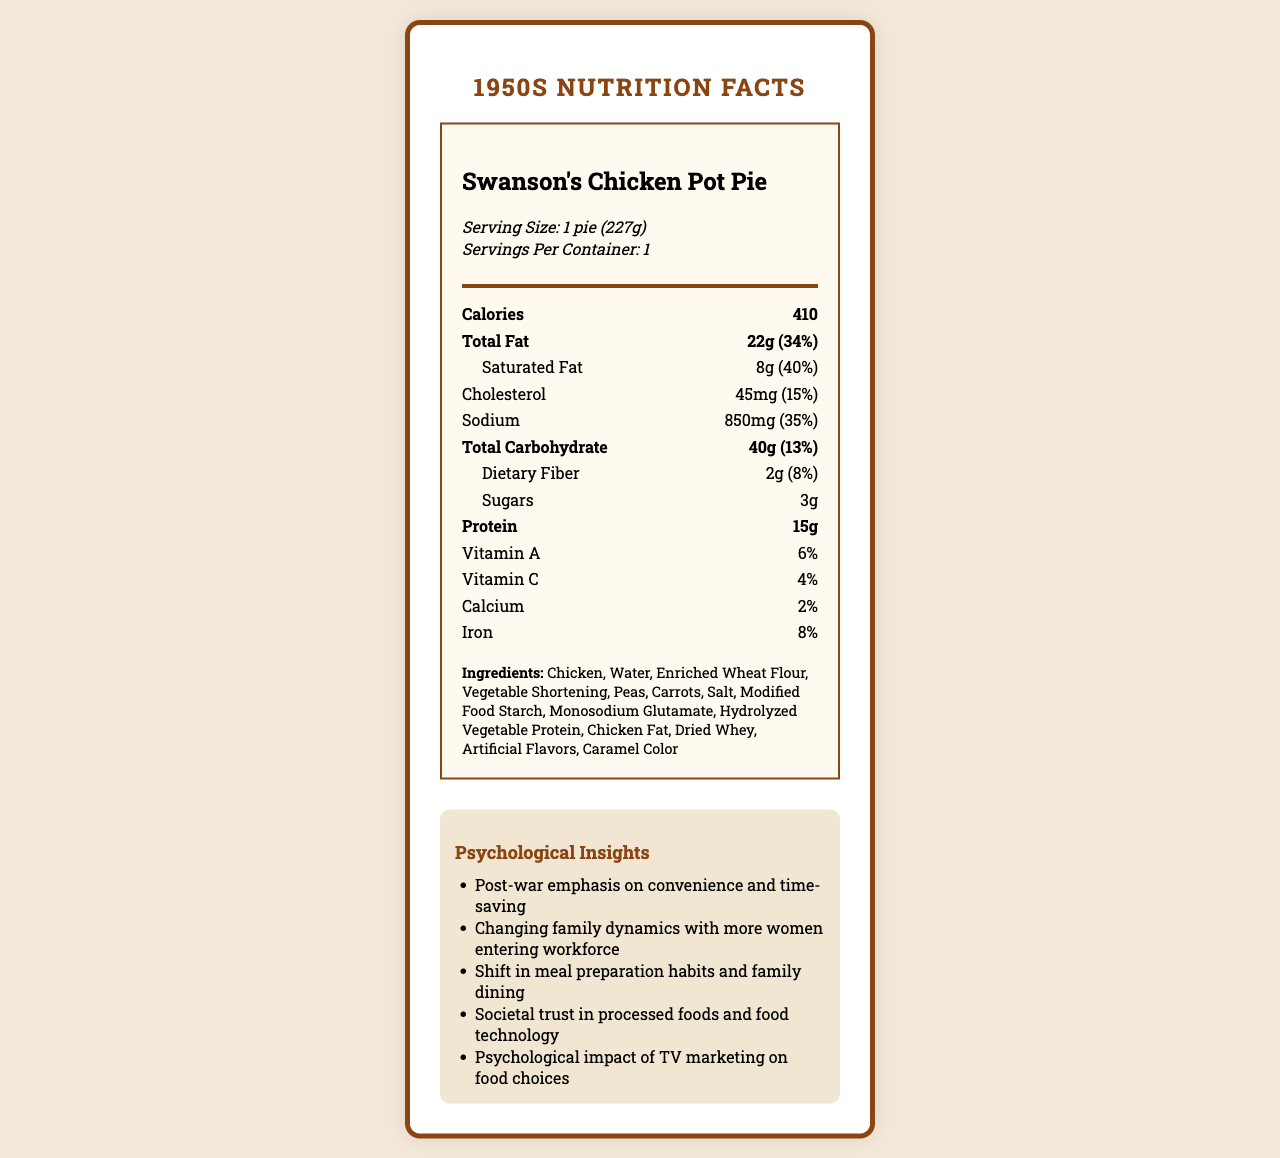how many servings are in the container? The document specifies "Serving Size: 1 pie (227g)" and "Servings Per Container: 1".
Answer: 1 what is the total carbohydrate content? The total carbohydrate content is listed as 40 grams in the document.
Answer: 40g how much protein does one serving provide? The document indicates that one serving includes 15 grams of protein.
Answer: 15g list three psychological insights reflected in the document. These insights are explicitly mentioned in the "Psychological Insights" section of the document.
Answer: Post-war emphasis on convenience and time-saving, Changing family dynamics with more women entering the workforce, Shift in meal preparation habits and family dining. name two ingredients in Swanson's Chicken Pot Pie that are used for flavoring. These ingredients are found in the "Ingredients" list provided in the document.
Answer: Monosodium Glutamate, Artificial Flavors What is the serving size of Swanson's Chicken Pot Pie? The serving size is given as "1 pie (227g)" in the document.
Answer: 1 pie (227g) Which nutrient has the highest daily value percentage? A. Sodium B. Total Fat C. Cholesterol D. Iron Total Fat has a daily value percentage of 34%, which is the highest among the listed nutrients.
Answer: B. Total Fat What was one reason for the introduction of Swanson's Chicken Pot Pie in the 1950s? A. To promote healthy eating B. To cater to vegetarians C. To provide convenient meal options for busy families The document mentions the post-war emphasis on convenience and the entry of more women into the workforce as part of the context leading to the introduction of convenience foods like TV dinners.
Answer: C. To provide convenient meal options for busy families Is Swanson's Chicken Pot Pie high in saturated fat? The document indicates that the saturated fat content is 8g, which is 40% of the daily value, suggesting it is high in saturated fat.
Answer: Yes Describe the main idea of the document. The document includes various sections presenting the nutritional facts, ingredients, psychological insights into food trends of the 1950s, and historical context surrounding the product's introduction.
Answer: The document is a 1950s Nutrition Facts Label for Swanson's Chicken Pot Pie, detailing its nutritional content, ingredients, and providing psychological insights into the post-war era's focus on convenience foods and changing family dynamics. What year was Swanson's Chicken Pot Pie introduced? The document does not specifically mention the year of introduction for Swanson's Chicken Pot Pie, though it references the 1950s era and post-WWII context.
Answer: Not enough information 